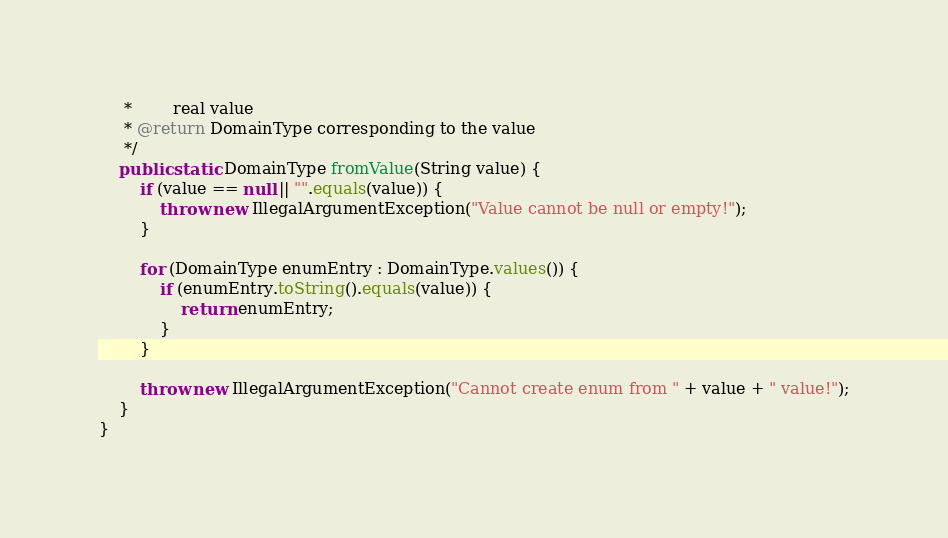Convert code to text. <code><loc_0><loc_0><loc_500><loc_500><_Java_>     *        real value
     * @return DomainType corresponding to the value
     */
    public static DomainType fromValue(String value) {
        if (value == null || "".equals(value)) {
            throw new IllegalArgumentException("Value cannot be null or empty!");
        }

        for (DomainType enumEntry : DomainType.values()) {
            if (enumEntry.toString().equals(value)) {
                return enumEntry;
            }
        }

        throw new IllegalArgumentException("Cannot create enum from " + value + " value!");
    }
}
</code> 